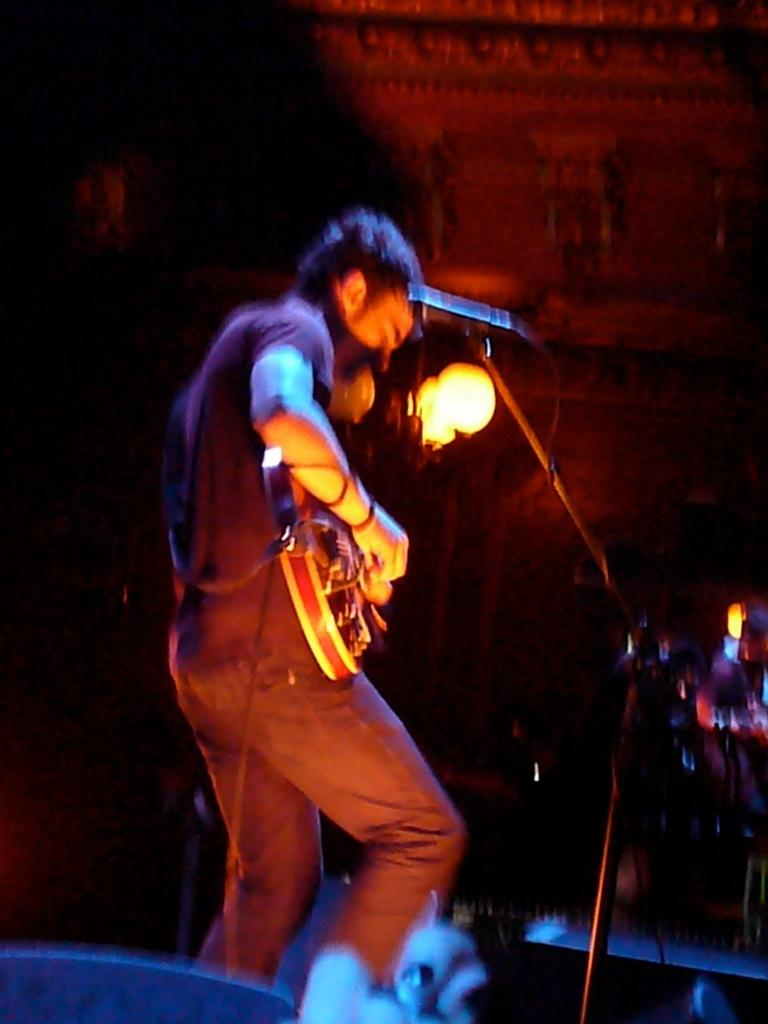What is the man in the image doing? The man is playing the guitar. What object is the man holding in the image? The man is holding a guitar. What is in front of the man that he might be using? There is a microphone and a light in front of the man. How would you describe the lighting in the image? The background of the image is dark. What type of tree can be seen in the image? There is no tree present in the image. What industry does the man work in, based on the image? The image does not provide enough information to determine the man's industry. 